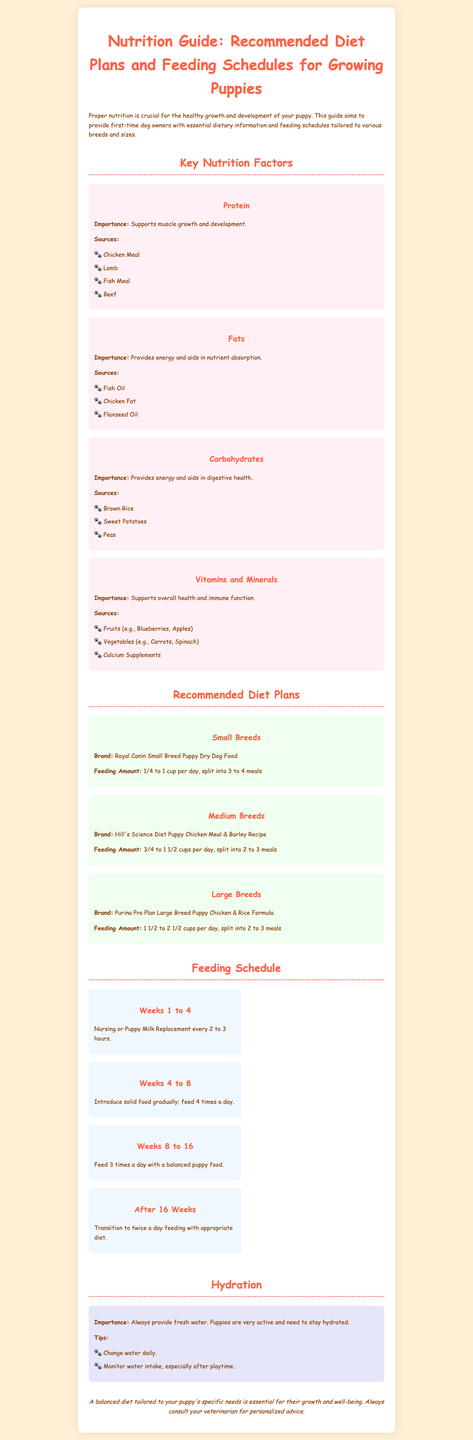What is the protein's importance for puppies? The importance of protein is that it supports muscle growth and development.
Answer: Supports muscle growth and development What are the recommended feeding amounts for small breed puppies? The recommended feeding amount for small breed puppies is 1/4 to 1 cup per day, split into 3 to 4 meals.
Answer: 1/4 to 1 cup per day Which brand is recommended for medium breed puppies? The brand recommended for medium breed puppies is Hill's Science Diet Puppy Chicken Meal & Barley Recipe.
Answer: Hill's Science Diet Puppy Chicken Meal & Barley Recipe What is a key source of fats for puppies? One key source of fats for puppies is Chicken Fat.
Answer: Chicken Fat How often should you feed puppies during weeks 4 to 8? During weeks 4 to 8, you should feed puppies 4 times a day.
Answer: 4 times a day What should be provided at all times for hydration? Fresh water should always be provided for hydration.
Answer: Fresh water What is the feeding schedule after 16 weeks? After 16 weeks, the feeding schedule transitions to twice a day feeding with an appropriate diet.
Answer: Twice a day feeding Which vitamin source is mentioned for puppies? One vitamin source mentioned for puppies is Blueberries.
Answer: Blueberries What are the two main components of puppy nutrition discussed in the document? The two main components discussed are Diet Plans and Feeding Schedules.
Answer: Diet Plans and Feeding Schedules 